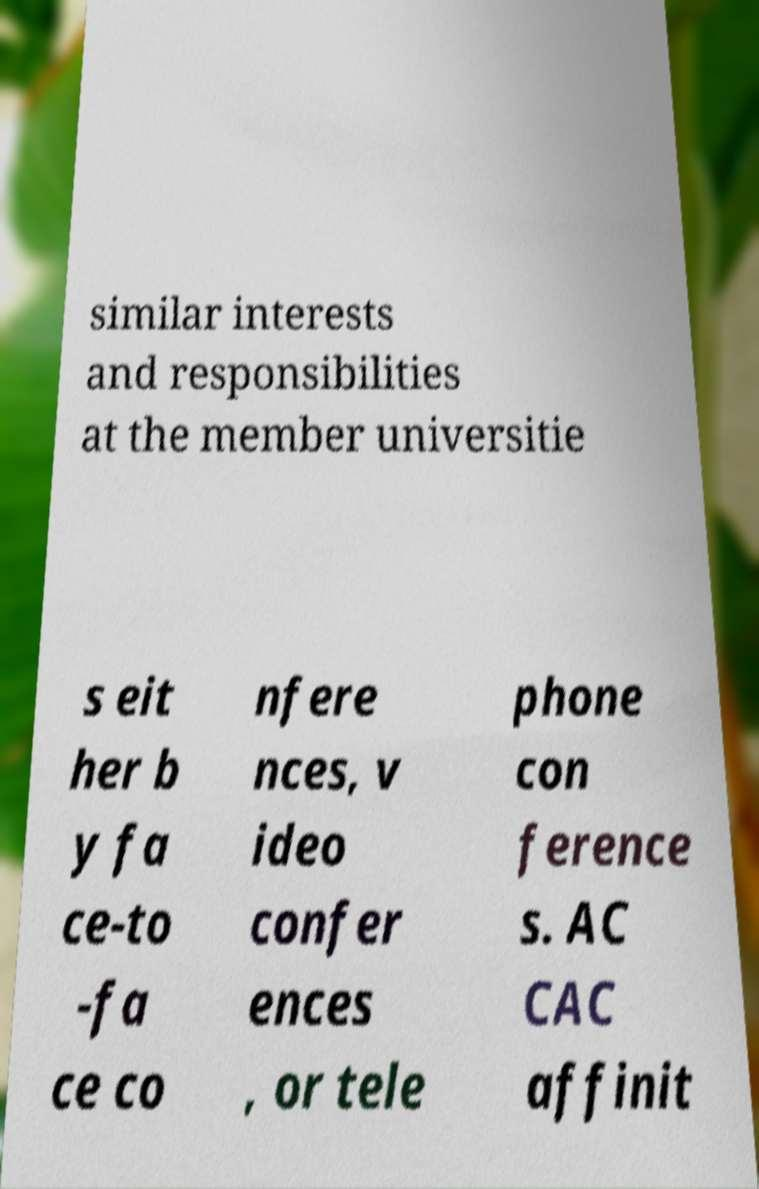Can you read and provide the text displayed in the image?This photo seems to have some interesting text. Can you extract and type it out for me? similar interests and responsibilities at the member universitie s eit her b y fa ce-to -fa ce co nfere nces, v ideo confer ences , or tele phone con ference s. AC CAC affinit 